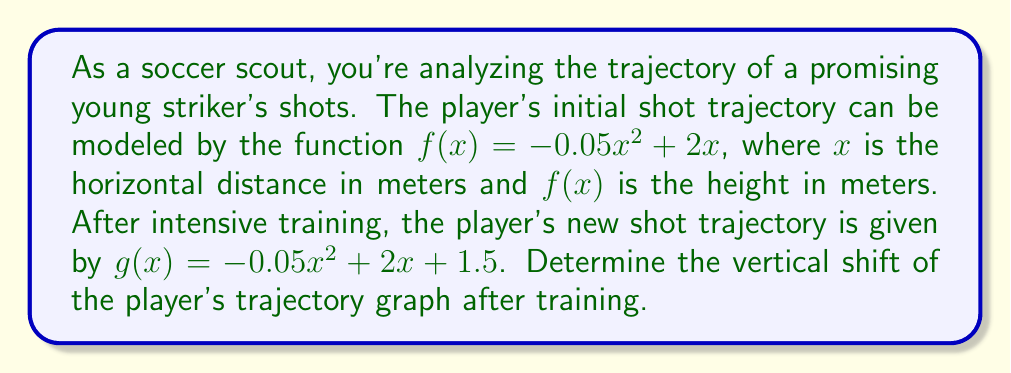Teach me how to tackle this problem. To determine the vertical shift of the player's trajectory graph, we need to compare the two functions:

1) Initial trajectory: $f(x) = -0.05x^2 + 2x$
2) New trajectory: $g(x) = -0.05x^2 + 2x + 1.5$

The general form of a vertical shift is:

$g(x) = f(x) + k$

where $k$ represents the vertical shift.

Comparing $f(x)$ and $g(x)$:

$g(x) = -0.05x^2 + 2x + 1.5$
$f(x) = -0.05x^2 + 2x$

We can see that $g(x)$ has an additional term of $+1.5$ compared to $f(x)$.

Therefore, $k = 1.5$

This means the graph of $g(x)$ is shifted 1.5 units upward compared to $f(x)$.

In soccer terms, this indicates that after training, the player's shots reach a height that is 1.5 meters higher at every point along the trajectory compared to their initial shots.
Answer: 1.5 meters upward 